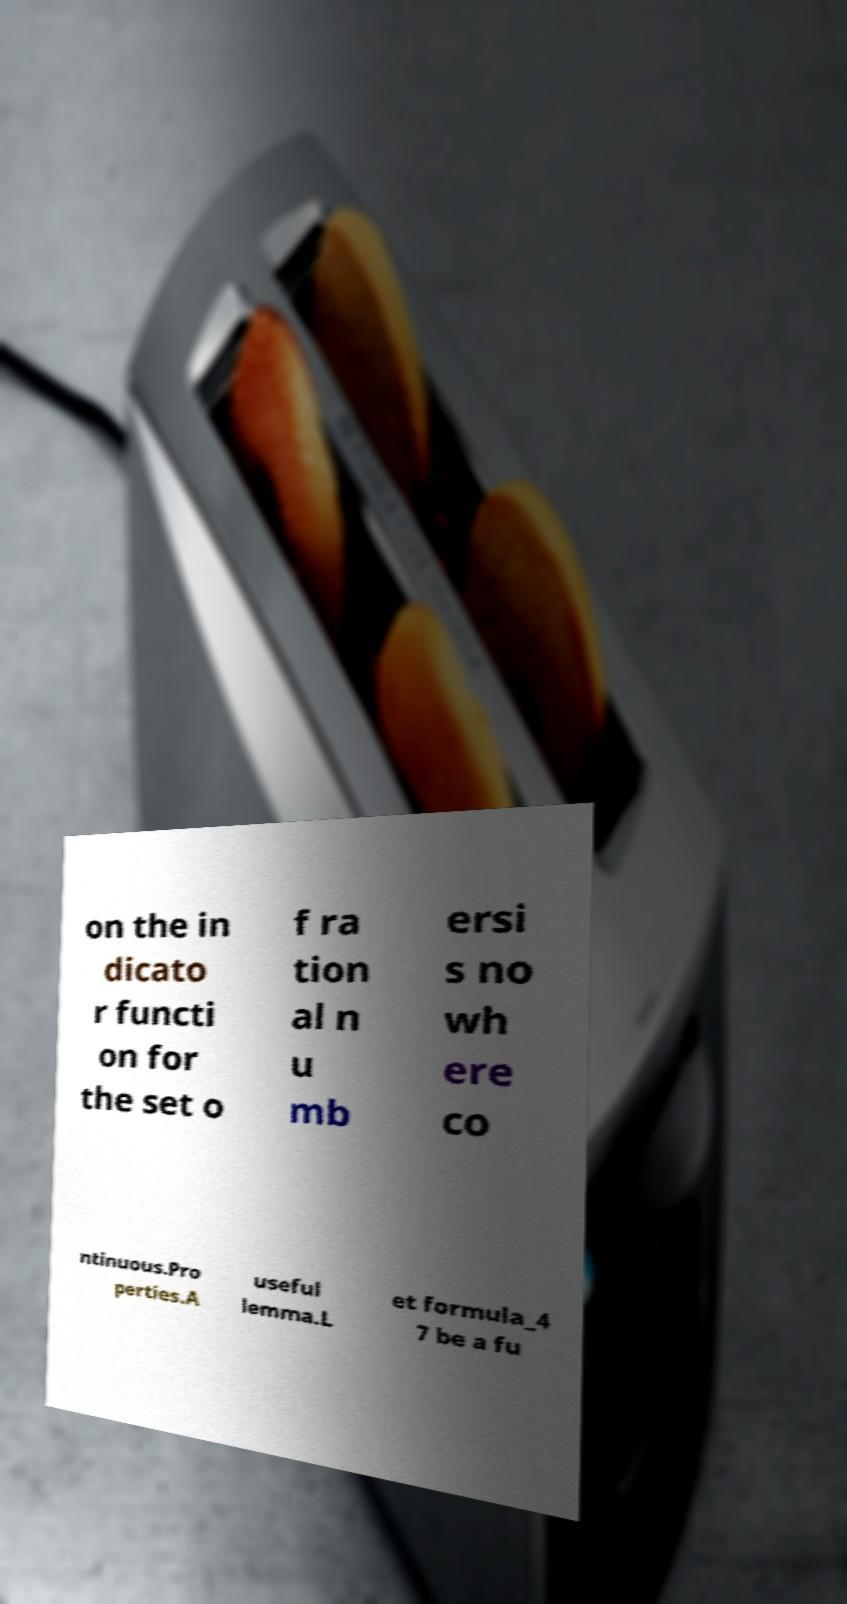Please identify and transcribe the text found in this image. on the in dicato r functi on for the set o f ra tion al n u mb ersi s no wh ere co ntinuous.Pro perties.A useful lemma.L et formula_4 7 be a fu 